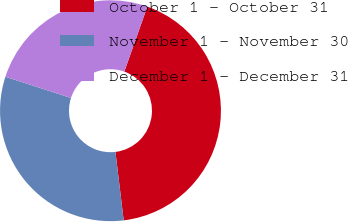Convert chart to OTSL. <chart><loc_0><loc_0><loc_500><loc_500><pie_chart><fcel>October 1 - October 31<fcel>November 1 - November 30<fcel>December 1 - December 31<nl><fcel>42.68%<fcel>31.89%<fcel>25.44%<nl></chart> 